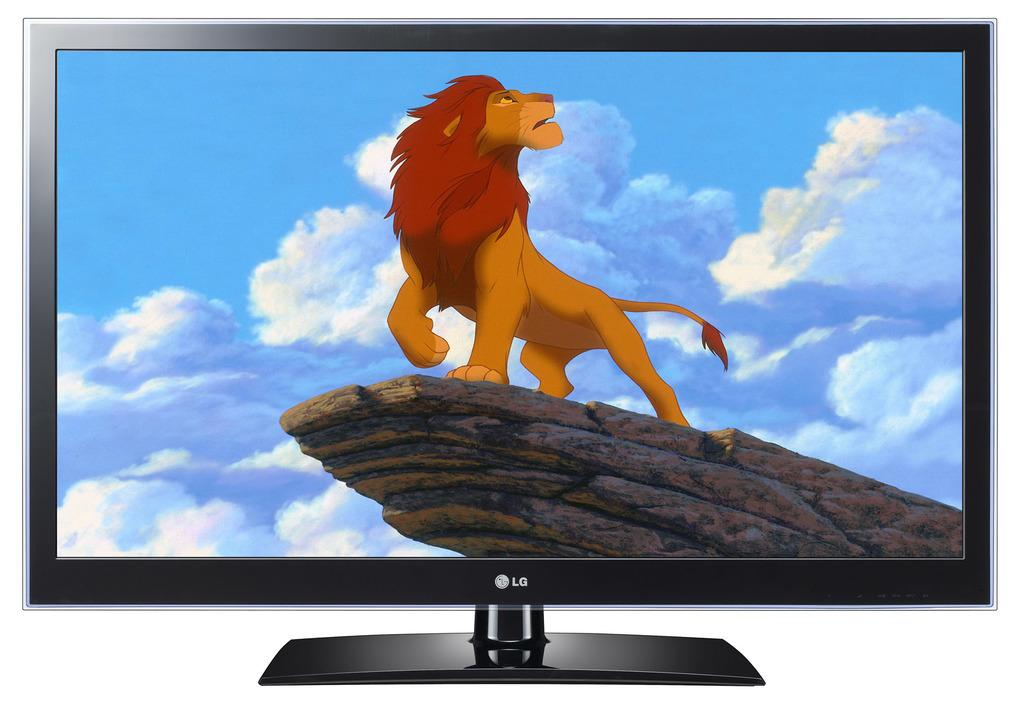<image>
Give a short and clear explanation of the subsequent image. An image from the Lion King is shown on an LG television. 